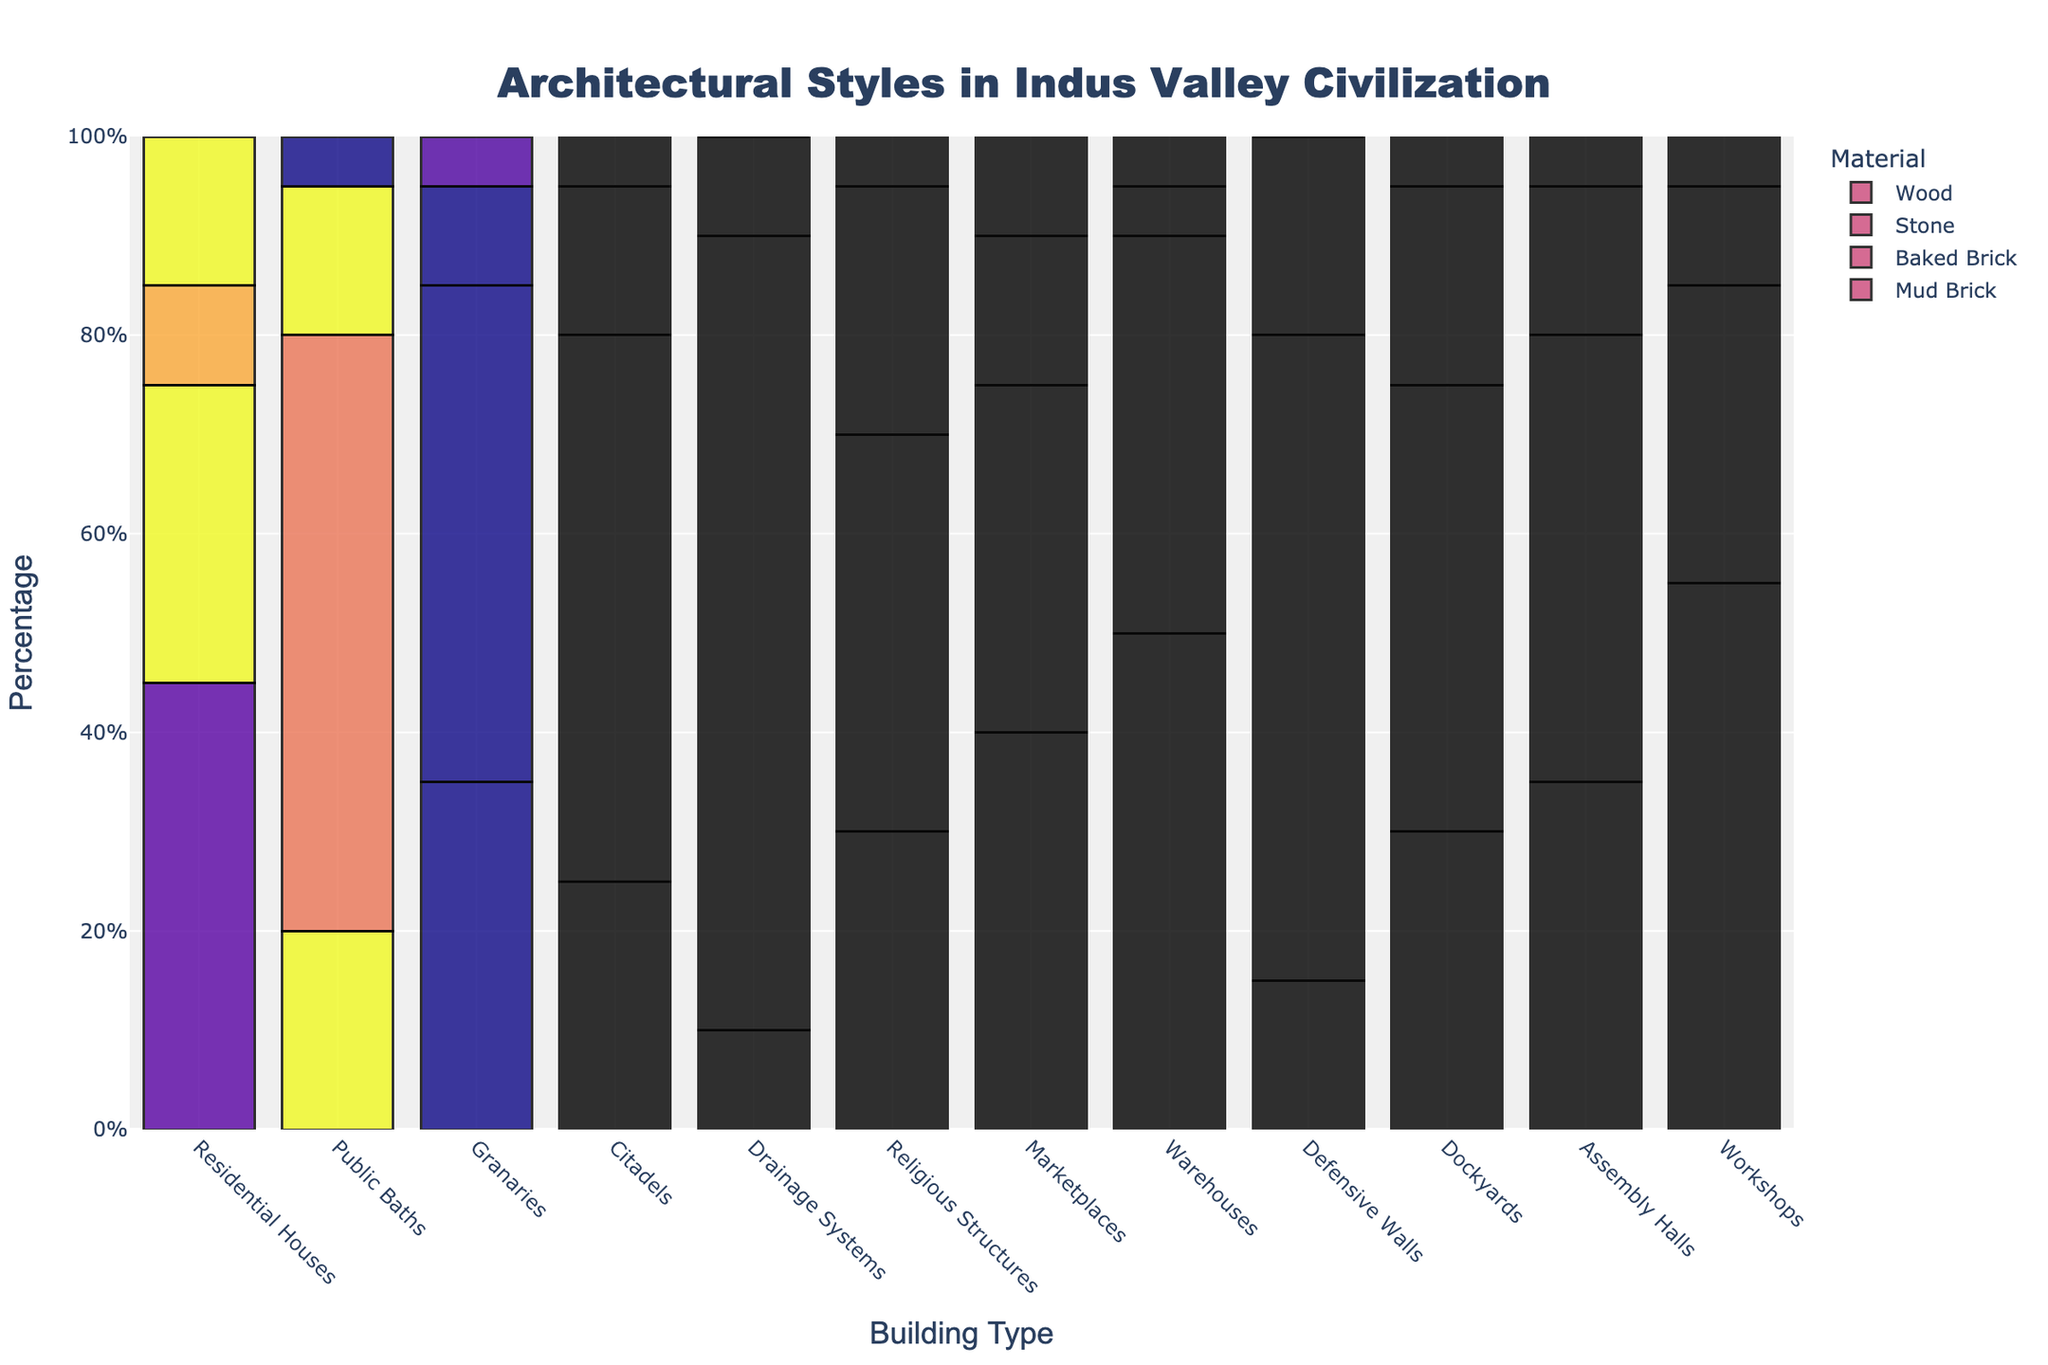what is the most common building material used for drainage systems? The bar for baked brick in the drainage systems category is the tallest among all materials, indicating it is the most commonly used material for drainage systems.
Answer: Baked Brick Which building type uses the least amount of wood? The chart shows the height of the wood bar across different building types, with drainage systems having a height of zero, indicating no wood usage.
Answer: Drainage Systems How many building types use stone as a building material? Counting the number of categories with a non-zero bar height for stone reveals all building types have stone usage.
Answer: 12 What materials are most commonly used in residential houses? Bars representing mud brick, baked brick, stone, and wood in the residential houses category are compared, with mud brick having the tallest bar, followed by baked brick.
Answer: Mud Brick, Baked Brick In which building type is stone used more than mud brick? Comparing the bar heights for stone and mud brick reveals that stones have higher bars in religious structures.
Answer: Religious Structures What is the total percentage of baked bricks used in citadels and defensive walls combined? The baked brick percentage for citadels is 55%, and for defensive walls, it's 65%; summing these values gives a total of 120%.
Answer: 120% Which building types use equal amounts of wood? Comparing the wood bars' heights across building types, all with a height of five are public baths, granaries, citadels, workshops, religious structures, and assembly halls.
Answer: Public Baths, Granaries, Citadels, Workshops, Religious Structures, Assembly Halls What is the total percentage of mud bricks used in workshops and marketplaces combined? The mud brick percentage for workshops is 55%, and for marketplaces, it's 40%; summing these values gives a total of 95%.
Answer: 95% What percentage of residential houses is not constructed with wood? The wood bar for residential houses is 15%, so the remaining construction materials account for 100% - 15% = 85%.
Answer: 85% Which building type has the highest percentage of baked bricks? By comparing the heights of the baked brick bars across all categories, the highest bar is found in drainage systems.
Answer: Drainage Systems 